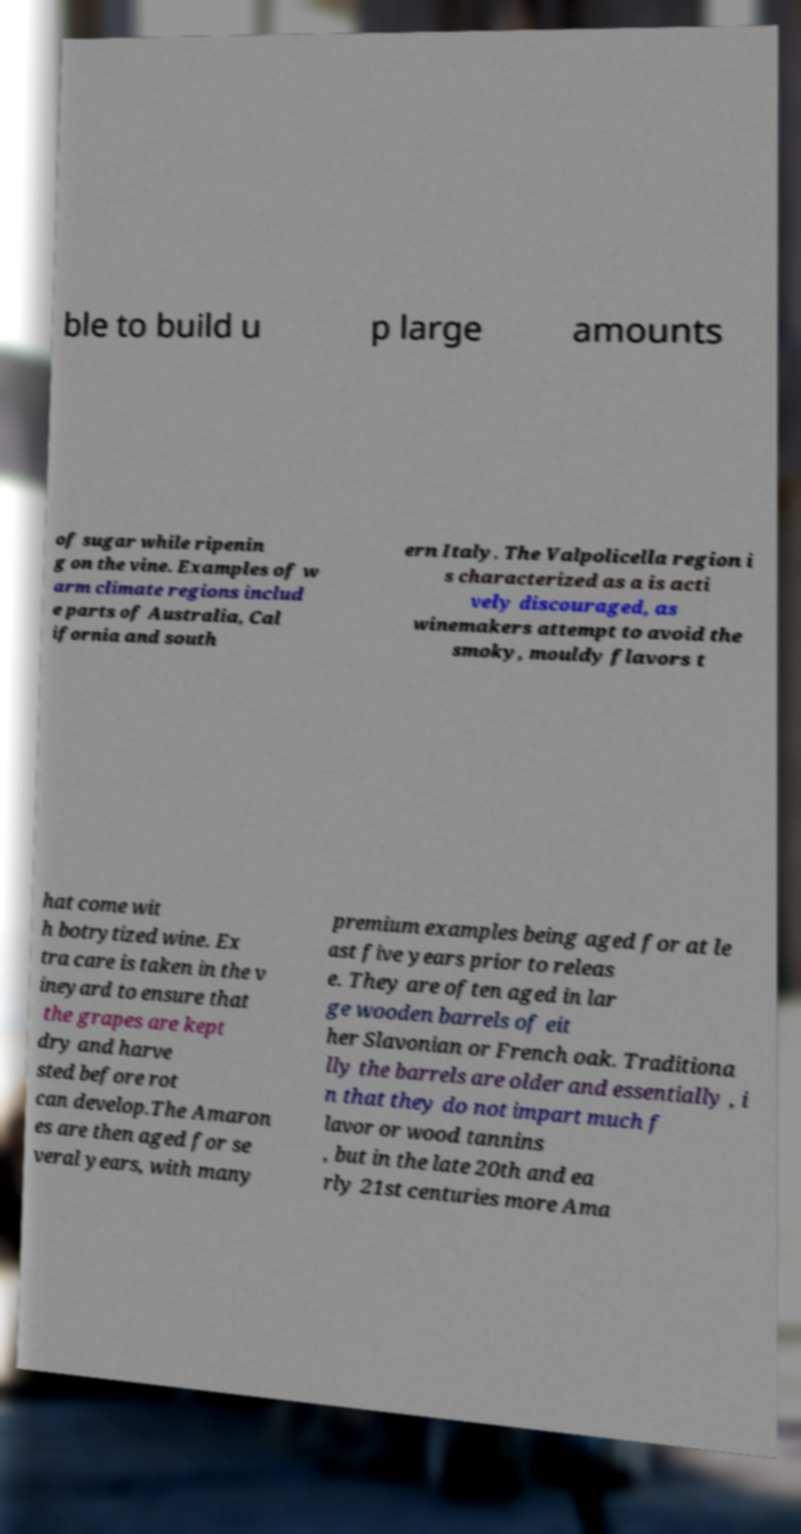Please identify and transcribe the text found in this image. ble to build u p large amounts of sugar while ripenin g on the vine. Examples of w arm climate regions includ e parts of Australia, Cal ifornia and south ern Italy. The Valpolicella region i s characterized as a is acti vely discouraged, as winemakers attempt to avoid the smoky, mouldy flavors t hat come wit h botrytized wine. Ex tra care is taken in the v ineyard to ensure that the grapes are kept dry and harve sted before rot can develop.The Amaron es are then aged for se veral years, with many premium examples being aged for at le ast five years prior to releas e. They are often aged in lar ge wooden barrels of eit her Slavonian or French oak. Traditiona lly the barrels are older and essentially , i n that they do not impart much f lavor or wood tannins , but in the late 20th and ea rly 21st centuries more Ama 